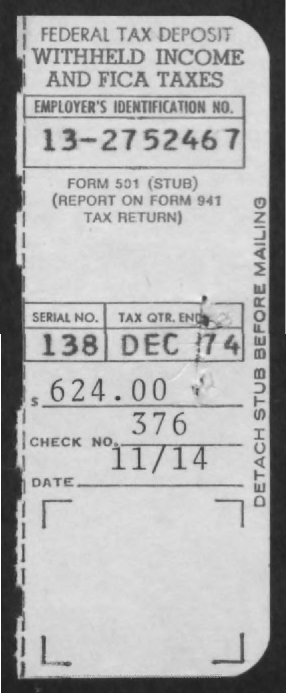What is check no?
Offer a very short reply. 376. What  is tax qtr end?
Your answer should be very brief. DEC 74. What is employer's identification number?
Keep it short and to the point. 13-2752467. 